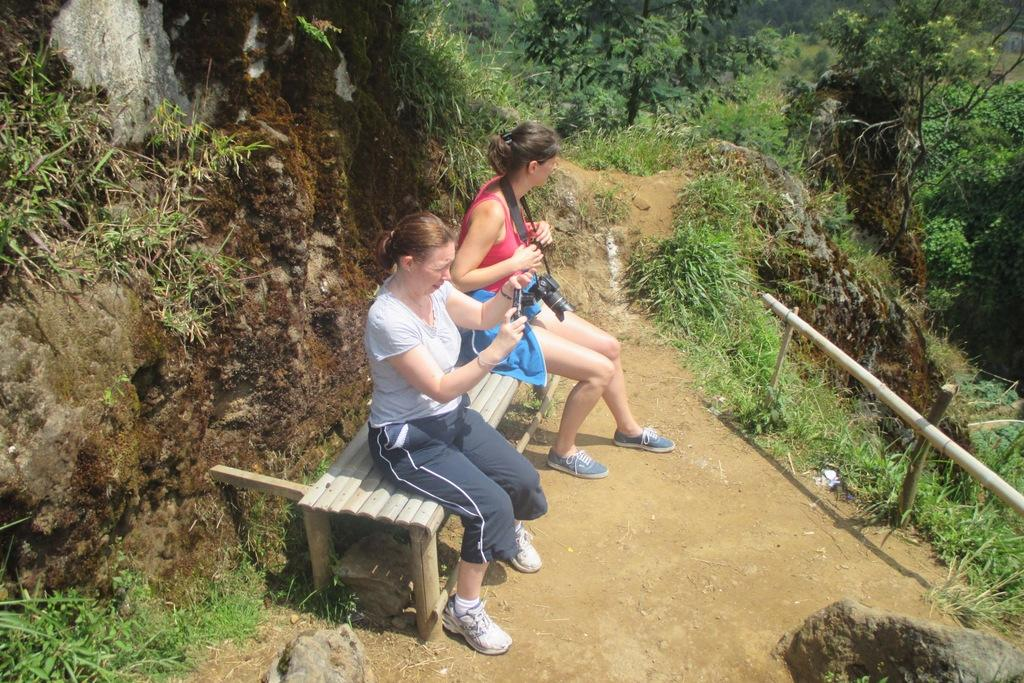How many women are in the image? There are 2 women in the image. What are the women sitting on? The women are sitting on a wooden bench. What are the women holding? The women are holding cameras. What can be seen at the front of the image? There are rocks at the front of the image. What type of vegetation is present in the image? There are plants in the image. What is in front of the women? There is a wooden fence in front of the women. What type of clover can be seen growing near the wooden fence? There is no clover visible in the image; only rocks, plants, and a wooden fence are present. What type of juice is the woman on the left drinking in the image? There is no juice present in the image; the women are holding cameras and sitting on a wooden bench. 